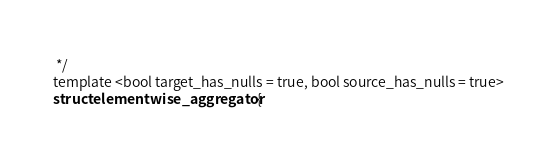Convert code to text. <code><loc_0><loc_0><loc_500><loc_500><_Cuda_> */
template <bool target_has_nulls = true, bool source_has_nulls = true>
struct elementwise_aggregator {</code> 